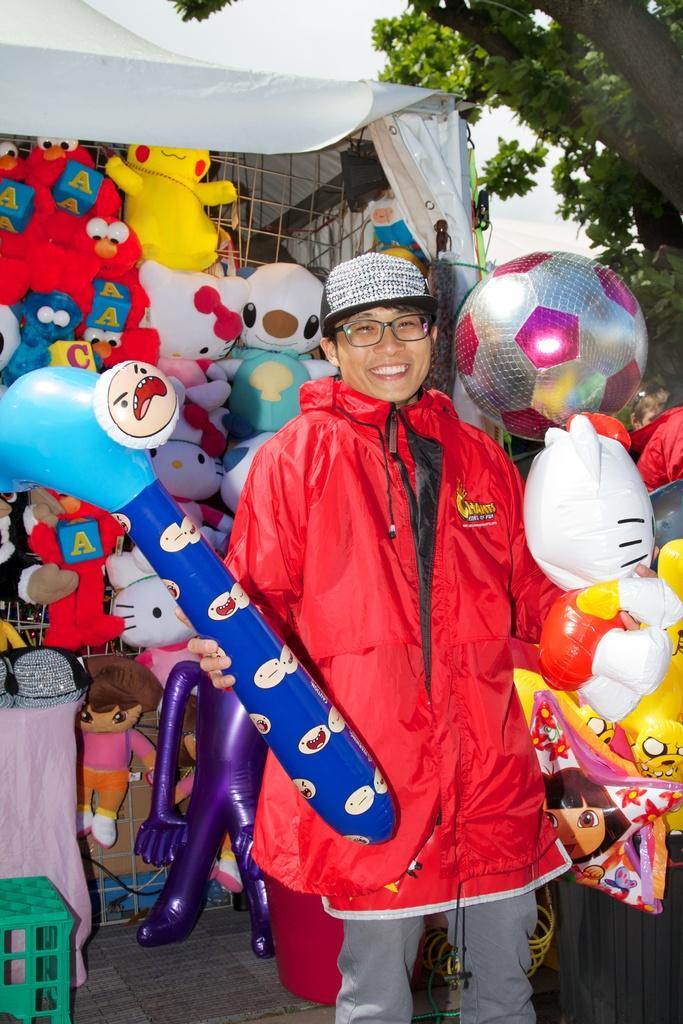In one or two sentences, can you explain what this image depicts? Here I can see a person wearing a red color jacket, standing, holding few toys in the hands, smiling and giving pose for the picture. At the bottom, I can see few tables on the floor. At the back of this person there are many toys are placed under the tent. In the top right there is a tree. 